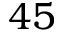<formula> <loc_0><loc_0><loc_500><loc_500>4 5</formula> 